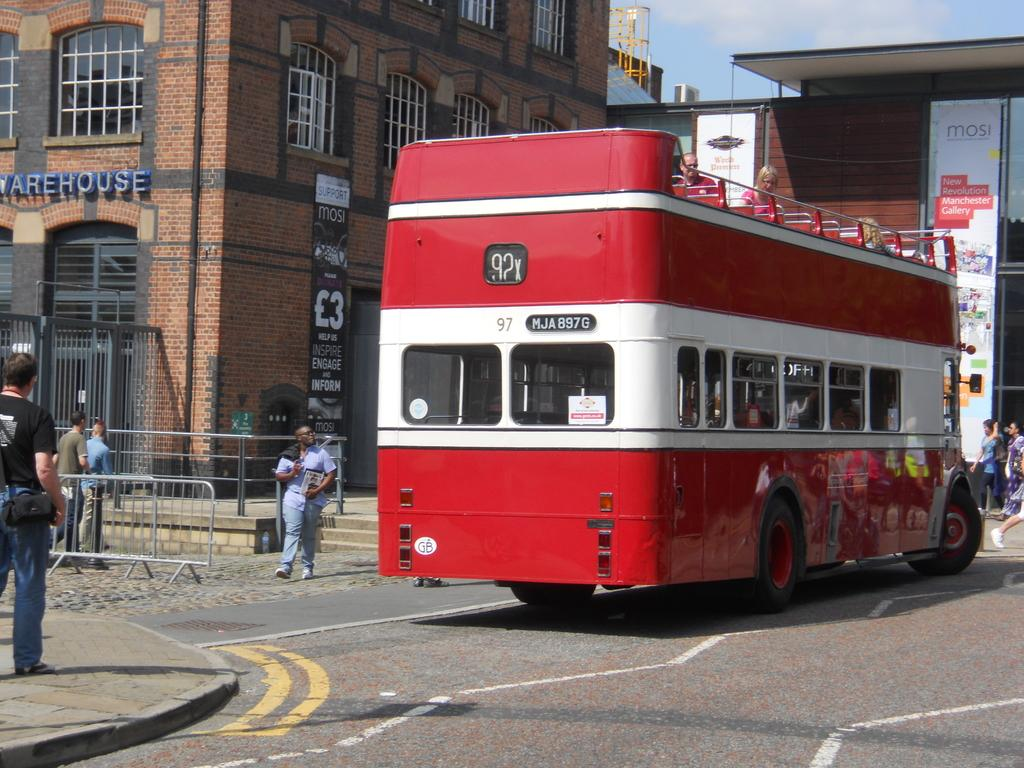<image>
Render a clear and concise summary of the photo. A white and red bus in the street has the number 97 on it. 